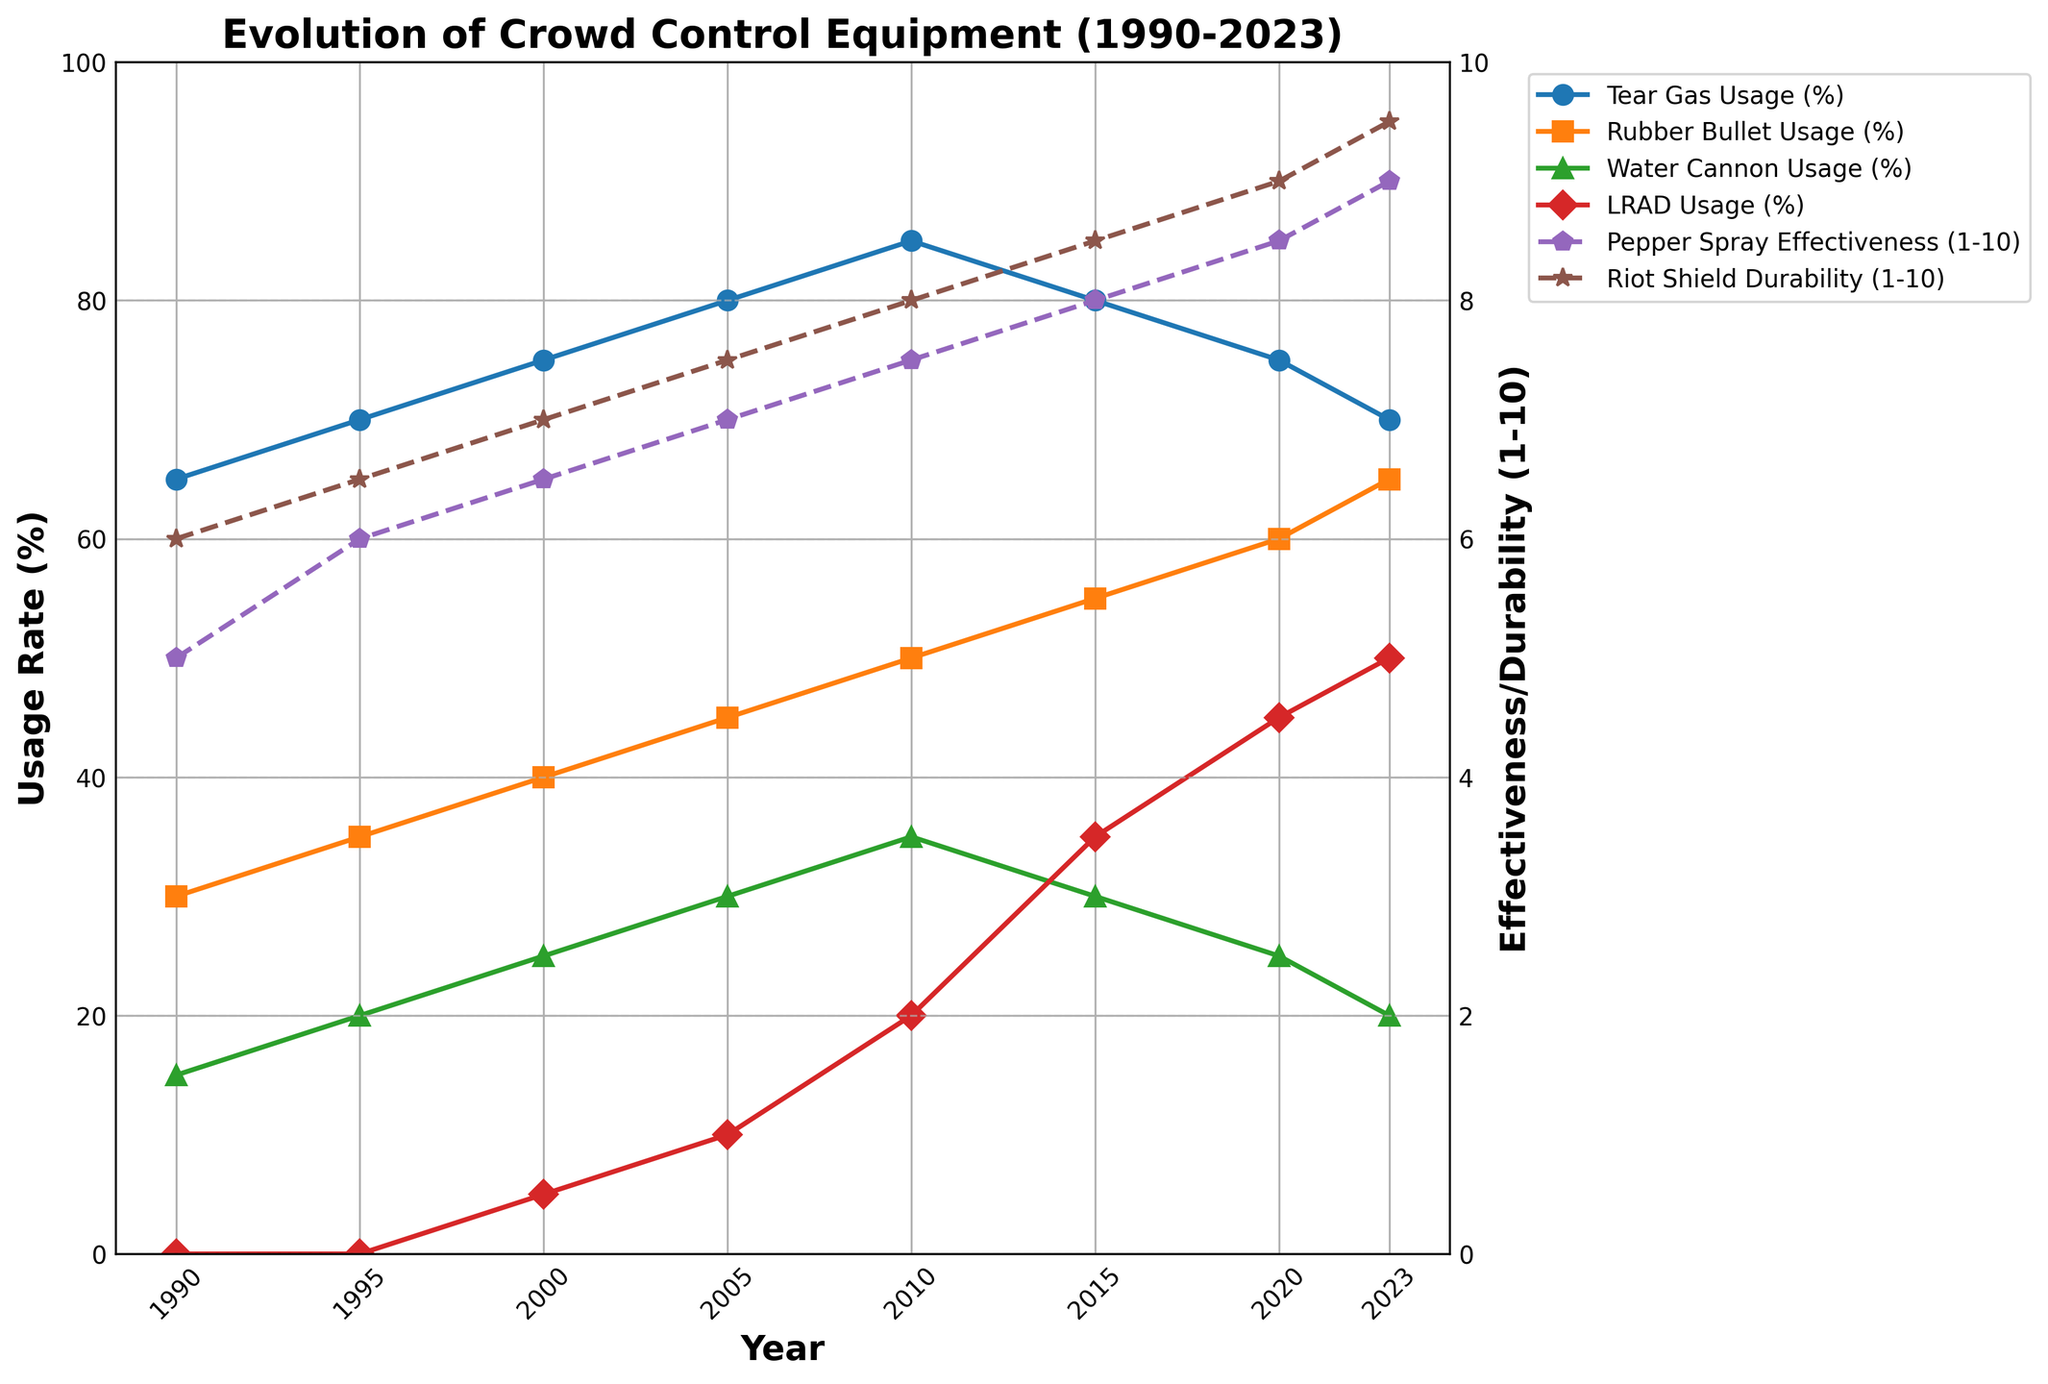What's the highest usage rate of tear gas, and when was it recorded? The figure shows tear gas usage as a line plot. By checking all the points, the highest value is 85%, which was recorded in 2010.
Answer: 85% in 2010 Which crowd control equipment had a steady increase in usage rate from 1990 to 2023? From the figure, LRAD shows a continuous upward trend starting from 0% in 1990 and reaching 50% by 2023.
Answer: LRAD How did the durability of riot shields change from 1995 to 2020? The second y-axis shows the durability in increments of 0.5. By checking the values from 1995 to 2020: it increased from 6.5 to 9.
Answer: Increased from 6.5 to 9 Compare the usage rates of rubber bullets and water cannons in 2020. Which was higher and by how much? The figure shows rubber bullets at 60% and water cannons at 25% in 2020. The difference is 60% - 25% = 35%.
Answer: Rubber bullets were higher by 35% Between 2010 and 2015, how did the effectiveness of pepper spray change? By looking at the trend line for pepper spray output, it increases from 7.5 in 2010 to 8 in 2015.
Answer: Increased from 7.5 to 8 Which year had the highest number of usage rate decreases, and for which equipment did these decreases occur? Looking at each line separately, 2015 to 2020 shows decreases in tear gas usage (85% to 80%) and water cannon usage (35% to 30%).
Answer: 2015-2020, for tear gas and water cannons What's the overall trend in the effectiveness of pepper spray from 1990 to 2023? Checking the pepper spray effectiveness curve, it shows an upward trend from 5 to 9.
Answer: Upward trend Given the trend lines, which crowd control equipment has been the most stable in durability over the years? The line for riot shield durability shows a steady increase with no drops, indicating stability.
Answer: Riot Shields For the years 2000 and 2010, which equipment saw a larger increase in usage rate: rubber bullets or water cannons? Checking the figure, rubber bullets increased from 40% to 50% (10%) and water cannons from 25% to 35% (10%). The increases are equal.
Answer: Both equal, 10% If a trend continues without any disruptions, what would the expected effectiveness of pepper spray be in 2025 based on the figure's trend? From 2015 to 2023, the effectiveness increased by 0.5 every 5 years, reaching 9 in 2023. If the trend continues, it would be 9.5 in 2025.
Answer: 9.5 